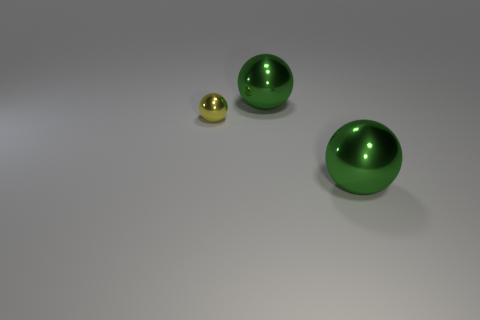What is the color of the large metal thing behind the tiny yellow object?
Your response must be concise. Green. What is the material of the big sphere behind the tiny metallic object?
Your response must be concise. Metal. What color is the small ball?
Ensure brevity in your answer.  Yellow. How many other things are there of the same shape as the small yellow metal thing?
Offer a terse response. 2. There is a big green metal sphere that is in front of the tiny yellow thing; is there a large ball on the right side of it?
Your response must be concise. No. How many small rubber cylinders are there?
Ensure brevity in your answer.  0. Is the number of big green shiny spheres greater than the number of large purple matte things?
Offer a terse response. Yes. How many other objects are the same size as the yellow metallic object?
Provide a succinct answer. 0. Does the tiny thing have the same material as the large sphere that is in front of the tiny yellow metallic thing?
Your answer should be compact. Yes. What number of other tiny things are made of the same material as the small yellow thing?
Ensure brevity in your answer.  0. 